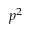<formula> <loc_0><loc_0><loc_500><loc_500>p ^ { 2 }</formula> 